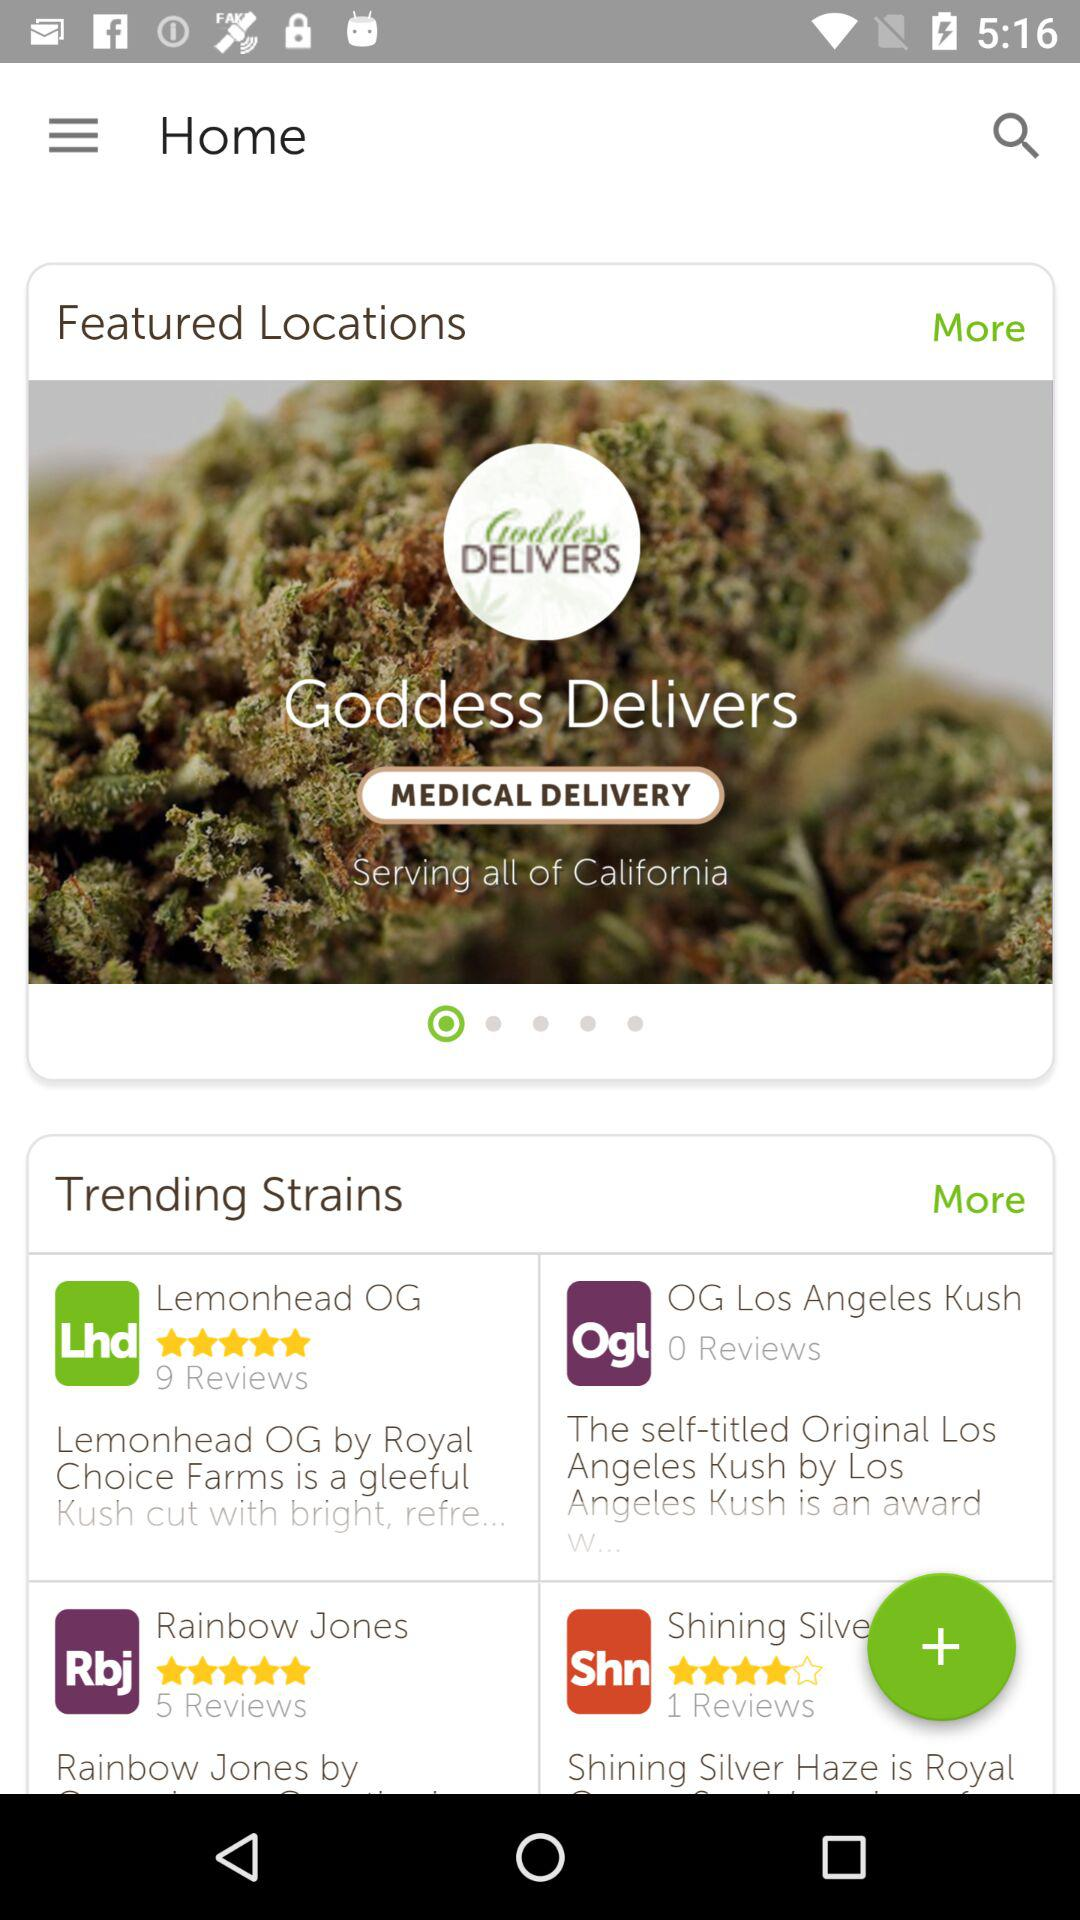What app delivers medical care? The "Goddess" app delivers medical care. 